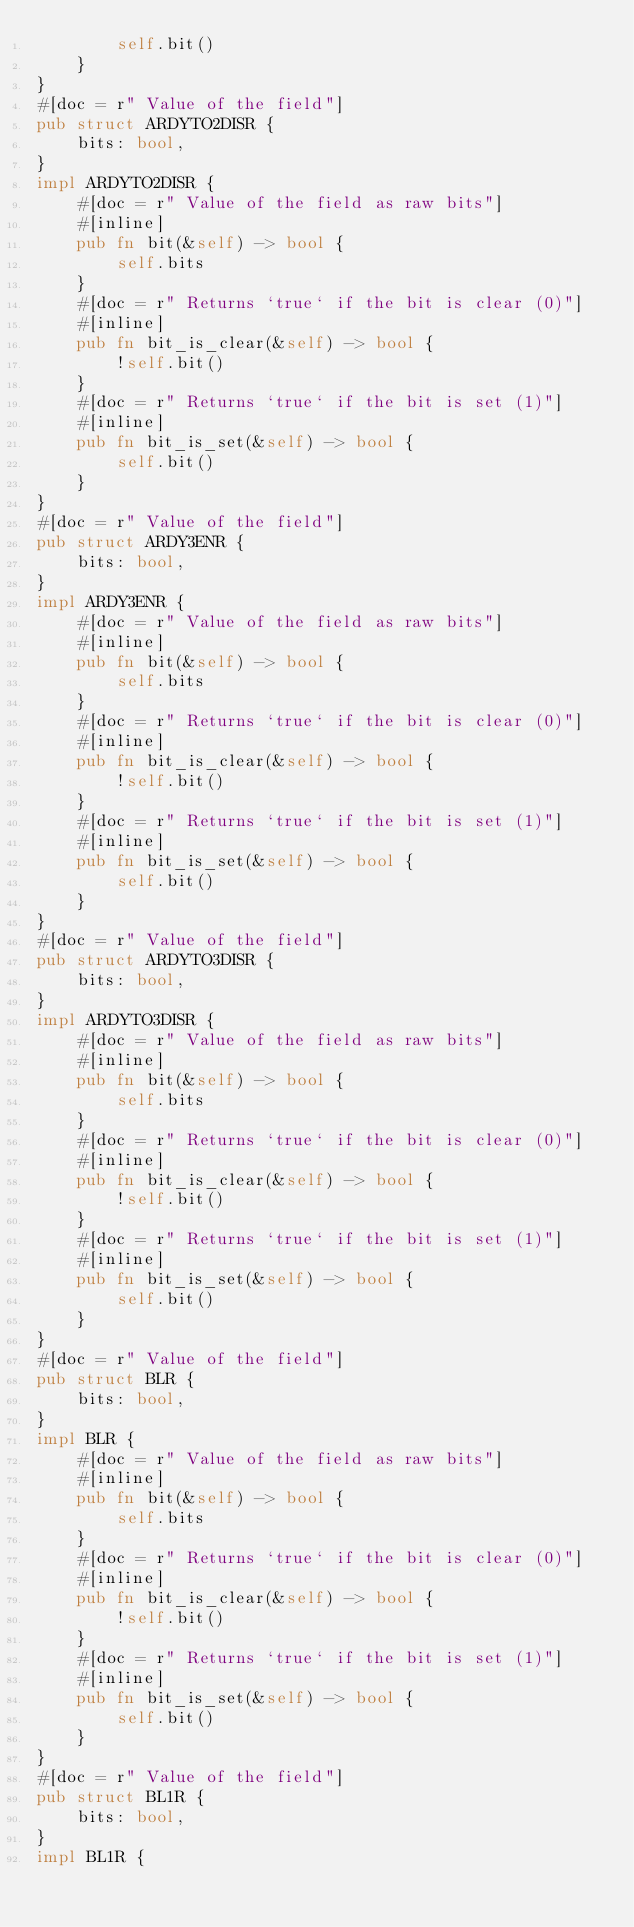<code> <loc_0><loc_0><loc_500><loc_500><_Rust_>        self.bit()
    }
}
#[doc = r" Value of the field"]
pub struct ARDYTO2DISR {
    bits: bool,
}
impl ARDYTO2DISR {
    #[doc = r" Value of the field as raw bits"]
    #[inline]
    pub fn bit(&self) -> bool {
        self.bits
    }
    #[doc = r" Returns `true` if the bit is clear (0)"]
    #[inline]
    pub fn bit_is_clear(&self) -> bool {
        !self.bit()
    }
    #[doc = r" Returns `true` if the bit is set (1)"]
    #[inline]
    pub fn bit_is_set(&self) -> bool {
        self.bit()
    }
}
#[doc = r" Value of the field"]
pub struct ARDY3ENR {
    bits: bool,
}
impl ARDY3ENR {
    #[doc = r" Value of the field as raw bits"]
    #[inline]
    pub fn bit(&self) -> bool {
        self.bits
    }
    #[doc = r" Returns `true` if the bit is clear (0)"]
    #[inline]
    pub fn bit_is_clear(&self) -> bool {
        !self.bit()
    }
    #[doc = r" Returns `true` if the bit is set (1)"]
    #[inline]
    pub fn bit_is_set(&self) -> bool {
        self.bit()
    }
}
#[doc = r" Value of the field"]
pub struct ARDYTO3DISR {
    bits: bool,
}
impl ARDYTO3DISR {
    #[doc = r" Value of the field as raw bits"]
    #[inline]
    pub fn bit(&self) -> bool {
        self.bits
    }
    #[doc = r" Returns `true` if the bit is clear (0)"]
    #[inline]
    pub fn bit_is_clear(&self) -> bool {
        !self.bit()
    }
    #[doc = r" Returns `true` if the bit is set (1)"]
    #[inline]
    pub fn bit_is_set(&self) -> bool {
        self.bit()
    }
}
#[doc = r" Value of the field"]
pub struct BLR {
    bits: bool,
}
impl BLR {
    #[doc = r" Value of the field as raw bits"]
    #[inline]
    pub fn bit(&self) -> bool {
        self.bits
    }
    #[doc = r" Returns `true` if the bit is clear (0)"]
    #[inline]
    pub fn bit_is_clear(&self) -> bool {
        !self.bit()
    }
    #[doc = r" Returns `true` if the bit is set (1)"]
    #[inline]
    pub fn bit_is_set(&self) -> bool {
        self.bit()
    }
}
#[doc = r" Value of the field"]
pub struct BL1R {
    bits: bool,
}
impl BL1R {</code> 